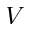<formula> <loc_0><loc_0><loc_500><loc_500>V</formula> 